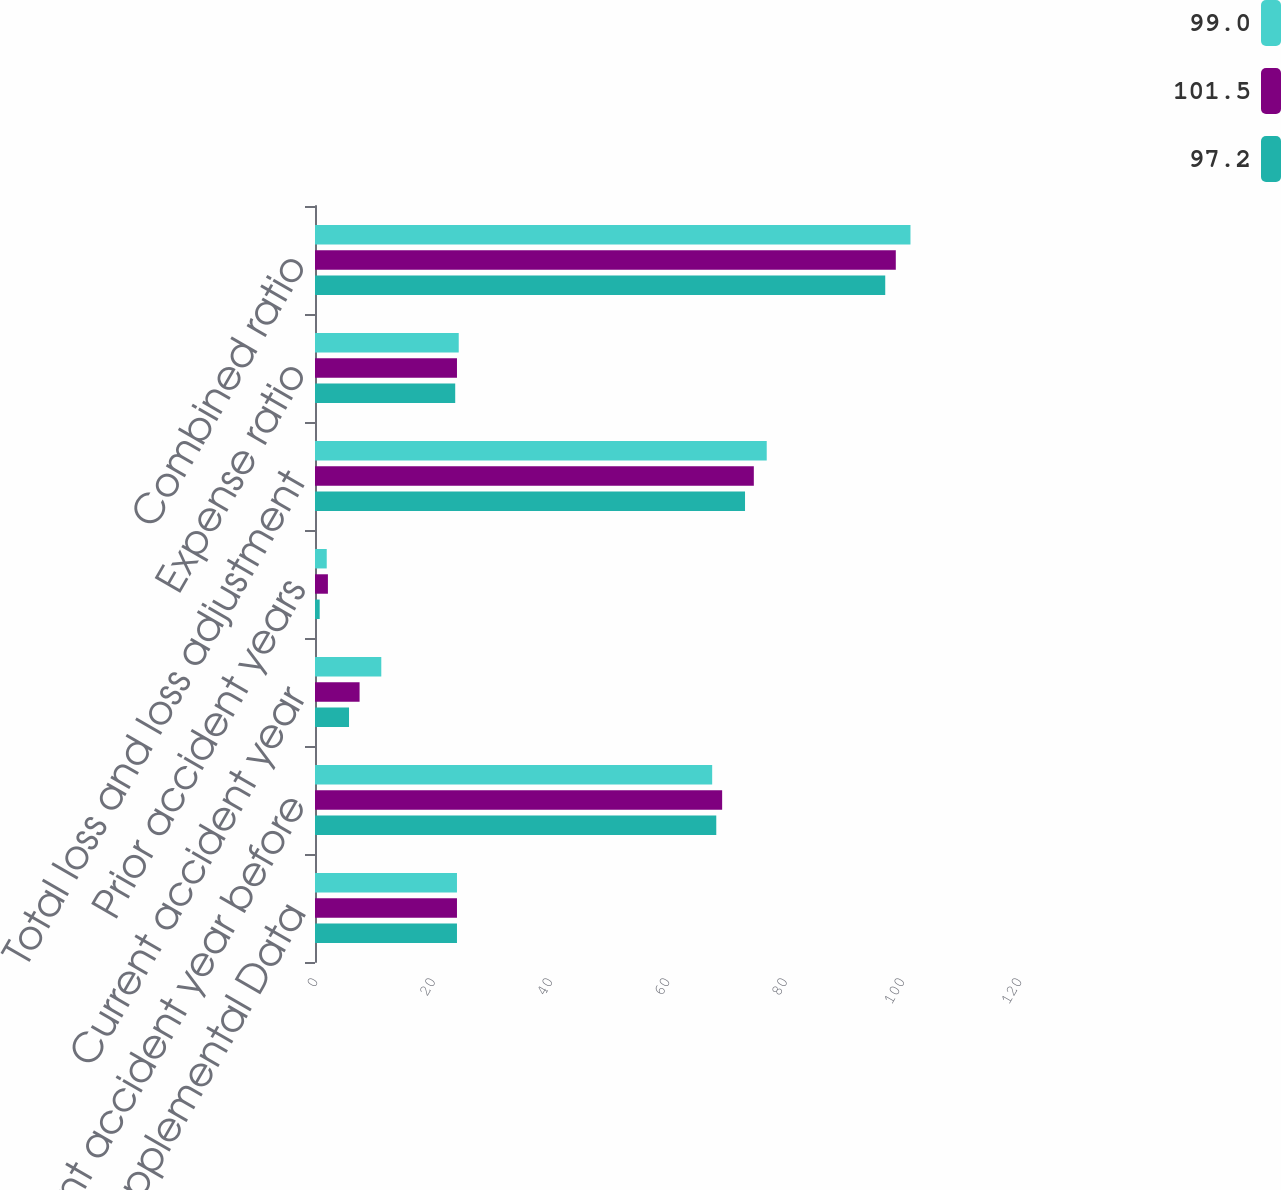Convert chart. <chart><loc_0><loc_0><loc_500><loc_500><stacked_bar_chart><ecel><fcel>Ratios and Supplemental Data<fcel>Current accident year before<fcel>Current accident year<fcel>Prior accident years<fcel>Total loss and loss adjustment<fcel>Expense ratio<fcel>Combined ratio<nl><fcel>99<fcel>24.2<fcel>67.7<fcel>11.3<fcel>2<fcel>77<fcel>24.5<fcel>101.5<nl><fcel>101.5<fcel>24.2<fcel>69.4<fcel>7.6<fcel>2.2<fcel>74.8<fcel>24.2<fcel>99<nl><fcel>97.2<fcel>24.2<fcel>68.4<fcel>5.8<fcel>0.8<fcel>73.3<fcel>23.9<fcel>97.2<nl></chart> 